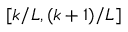Convert formula to latex. <formula><loc_0><loc_0><loc_500><loc_500>[ k / L , ( k + 1 ) / L ]</formula> 